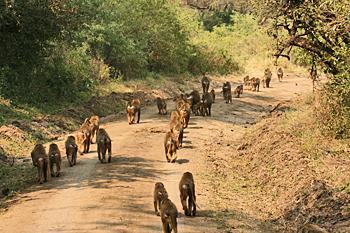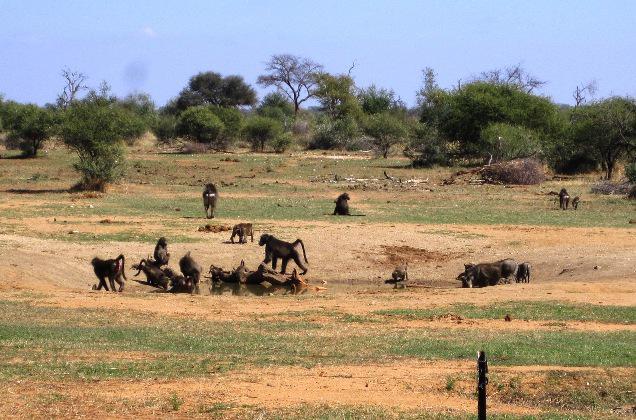The first image is the image on the left, the second image is the image on the right. Given the left and right images, does the statement "Baboons are walking along a dirt path flanked by bushes and trees in one image." hold true? Answer yes or no. Yes. The first image is the image on the left, the second image is the image on the right. For the images shown, is this caption "There are at most 3 baboons in the left image." true? Answer yes or no. No. 